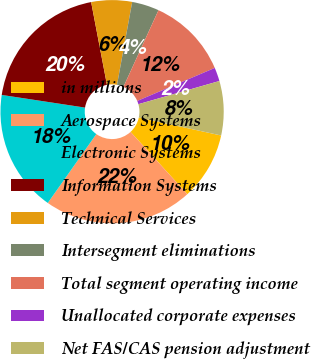Convert chart. <chart><loc_0><loc_0><loc_500><loc_500><pie_chart><fcel>in millions<fcel>Aerospace Systems<fcel>Electronic Systems<fcel>Information Systems<fcel>Technical Services<fcel>Intersegment eliminations<fcel>Total segment operating income<fcel>Unallocated corporate expenses<fcel>Net FAS/CAS pension adjustment<nl><fcel>9.81%<fcel>21.54%<fcel>17.63%<fcel>19.59%<fcel>5.89%<fcel>3.94%<fcel>11.76%<fcel>1.98%<fcel>7.85%<nl></chart> 